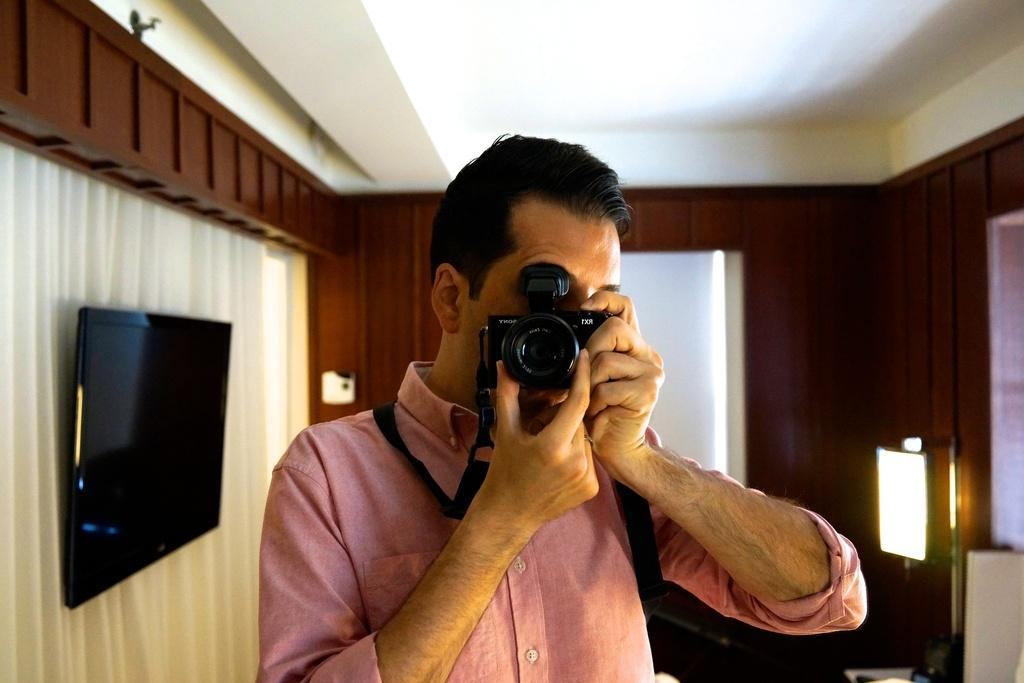Who is the main subject in the image? There is a man in the image. What is the man holding in the image? The man is holding a camera with both hands. What can be seen in the background of the image? There is a television, a curtain, and a lamp in the background of the image. What type of fog can be seen in the image? There is no fog present in the image. 